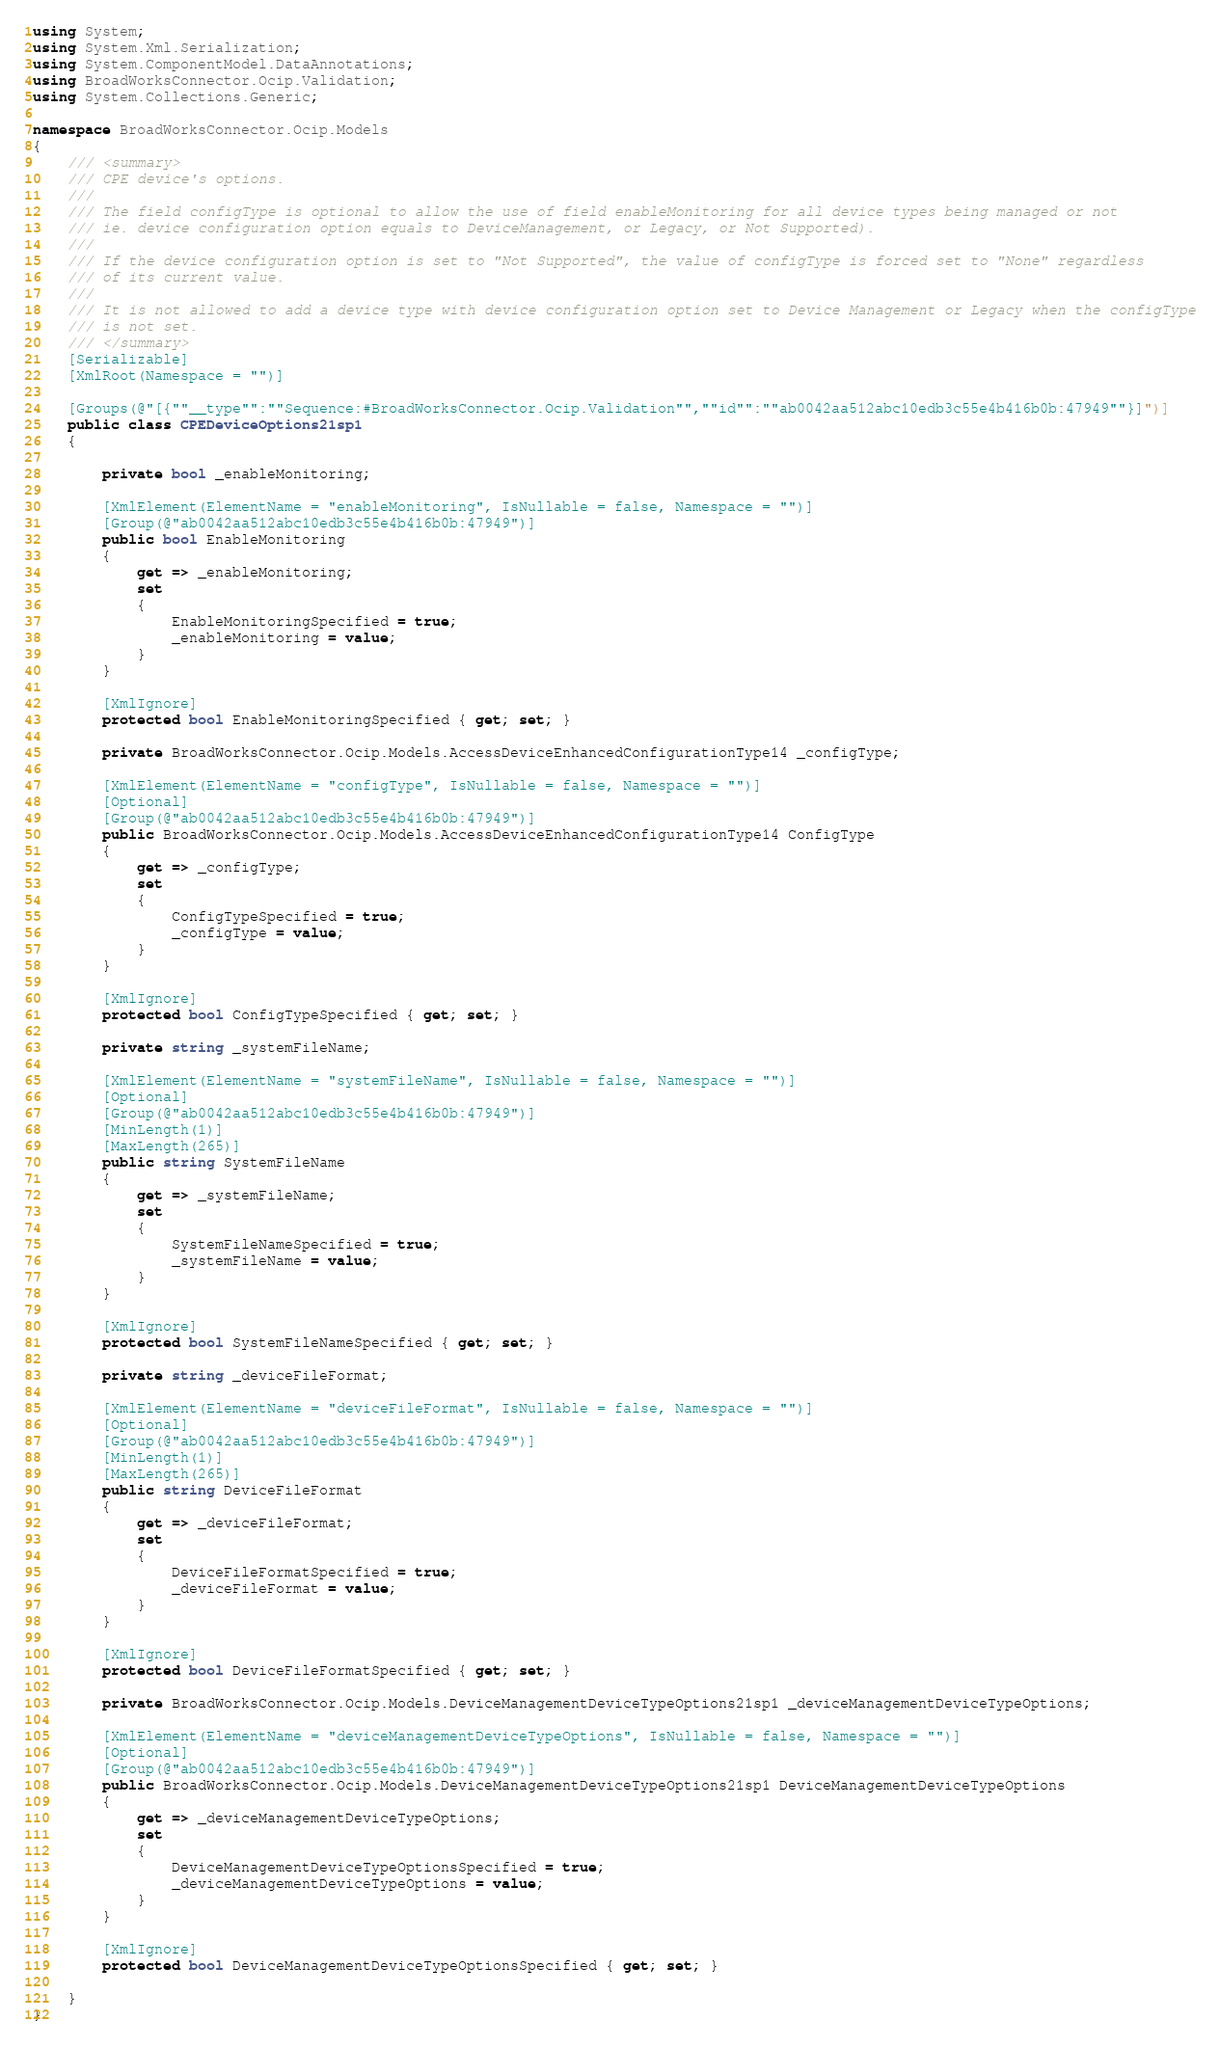<code> <loc_0><loc_0><loc_500><loc_500><_C#_>using System;
using System.Xml.Serialization;
using System.ComponentModel.DataAnnotations;
using BroadWorksConnector.Ocip.Validation;
using System.Collections.Generic;

namespace BroadWorksConnector.Ocip.Models
{
    /// <summary>
    /// CPE device's options.
    /// 
    /// The field configType is optional to allow the use of field enableMonitoring for all device types being managed or not
    /// ie. device configuration option equals to DeviceManagement, or Legacy, or Not Supported).
    /// 
    /// If the device configuration option is set to "Not Supported", the value of configType is forced set to "None" regardless
    /// of its current value.
    /// 
    /// It is not allowed to add a device type with device configuration option set to Device Management or Legacy when the configType
    /// is not set.
    /// </summary>
    [Serializable]
    [XmlRoot(Namespace = "")]

    [Groups(@"[{""__type"":""Sequence:#BroadWorksConnector.Ocip.Validation"",""id"":""ab0042aa512abc10edb3c55e4b416b0b:47949""}]")]
    public class CPEDeviceOptions21sp1
    {

        private bool _enableMonitoring;

        [XmlElement(ElementName = "enableMonitoring", IsNullable = false, Namespace = "")]
        [Group(@"ab0042aa512abc10edb3c55e4b416b0b:47949")]
        public bool EnableMonitoring
        {
            get => _enableMonitoring;
            set
            {
                EnableMonitoringSpecified = true;
                _enableMonitoring = value;
            }
        }

        [XmlIgnore]
        protected bool EnableMonitoringSpecified { get; set; }

        private BroadWorksConnector.Ocip.Models.AccessDeviceEnhancedConfigurationType14 _configType;

        [XmlElement(ElementName = "configType", IsNullable = false, Namespace = "")]
        [Optional]
        [Group(@"ab0042aa512abc10edb3c55e4b416b0b:47949")]
        public BroadWorksConnector.Ocip.Models.AccessDeviceEnhancedConfigurationType14 ConfigType
        {
            get => _configType;
            set
            {
                ConfigTypeSpecified = true;
                _configType = value;
            }
        }

        [XmlIgnore]
        protected bool ConfigTypeSpecified { get; set; }

        private string _systemFileName;

        [XmlElement(ElementName = "systemFileName", IsNullable = false, Namespace = "")]
        [Optional]
        [Group(@"ab0042aa512abc10edb3c55e4b416b0b:47949")]
        [MinLength(1)]
        [MaxLength(265)]
        public string SystemFileName
        {
            get => _systemFileName;
            set
            {
                SystemFileNameSpecified = true;
                _systemFileName = value;
            }
        }

        [XmlIgnore]
        protected bool SystemFileNameSpecified { get; set; }

        private string _deviceFileFormat;

        [XmlElement(ElementName = "deviceFileFormat", IsNullable = false, Namespace = "")]
        [Optional]
        [Group(@"ab0042aa512abc10edb3c55e4b416b0b:47949")]
        [MinLength(1)]
        [MaxLength(265)]
        public string DeviceFileFormat
        {
            get => _deviceFileFormat;
            set
            {
                DeviceFileFormatSpecified = true;
                _deviceFileFormat = value;
            }
        }

        [XmlIgnore]
        protected bool DeviceFileFormatSpecified { get; set; }

        private BroadWorksConnector.Ocip.Models.DeviceManagementDeviceTypeOptions21sp1 _deviceManagementDeviceTypeOptions;

        [XmlElement(ElementName = "deviceManagementDeviceTypeOptions", IsNullable = false, Namespace = "")]
        [Optional]
        [Group(@"ab0042aa512abc10edb3c55e4b416b0b:47949")]
        public BroadWorksConnector.Ocip.Models.DeviceManagementDeviceTypeOptions21sp1 DeviceManagementDeviceTypeOptions
        {
            get => _deviceManagementDeviceTypeOptions;
            set
            {
                DeviceManagementDeviceTypeOptionsSpecified = true;
                _deviceManagementDeviceTypeOptions = value;
            }
        }

        [XmlIgnore]
        protected bool DeviceManagementDeviceTypeOptionsSpecified { get; set; }

    }
}
</code> 